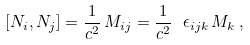<formula> <loc_0><loc_0><loc_500><loc_500>[ N _ { i } , N _ { j } ] = \frac { 1 } { c ^ { 2 } } \, M _ { i j } = \frac { 1 } { c ^ { 2 } } \ \epsilon _ { i j k } \, M _ { k } \, ,</formula> 